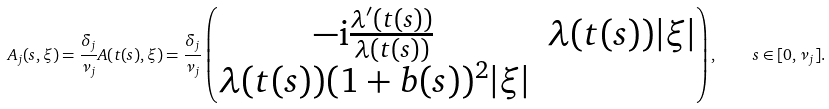<formula> <loc_0><loc_0><loc_500><loc_500>A _ { j } ( s , \xi ) = \frac { \delta _ { j } } { \nu _ { j } } A ( t ( s ) , \xi ) = \frac { \delta _ { j } } { \nu _ { j } } \begin{pmatrix} - \mathrm i \frac { \lambda ^ { \prime } ( t ( s ) ) } { \lambda ( t ( s ) ) } & \lambda ( t ( s ) ) | \xi | \\ \lambda ( t ( s ) ) ( 1 + b ( s ) ) ^ { 2 } | \xi | \end{pmatrix} , \quad s \in [ 0 , \nu _ { j } ] .</formula> 